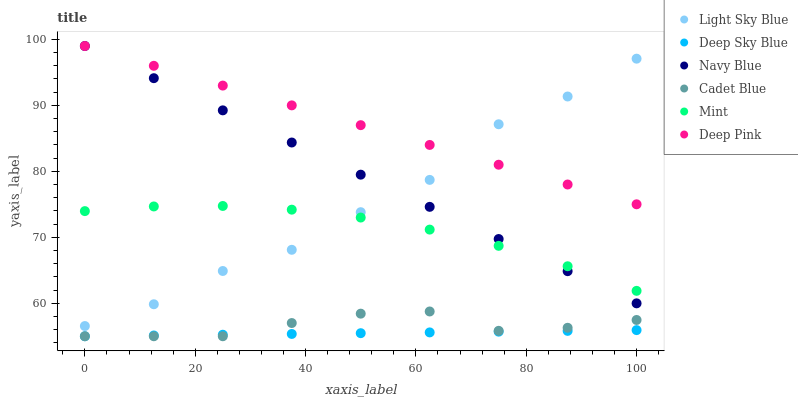Does Deep Sky Blue have the minimum area under the curve?
Answer yes or no. Yes. Does Deep Pink have the maximum area under the curve?
Answer yes or no. Yes. Does Navy Blue have the minimum area under the curve?
Answer yes or no. No. Does Navy Blue have the maximum area under the curve?
Answer yes or no. No. Is Navy Blue the smoothest?
Answer yes or no. Yes. Is Light Sky Blue the roughest?
Answer yes or no. Yes. Is Deep Pink the smoothest?
Answer yes or no. No. Is Deep Pink the roughest?
Answer yes or no. No. Does Cadet Blue have the lowest value?
Answer yes or no. Yes. Does Navy Blue have the lowest value?
Answer yes or no. No. Does Deep Pink have the highest value?
Answer yes or no. Yes. Does Light Sky Blue have the highest value?
Answer yes or no. No. Is Cadet Blue less than Navy Blue?
Answer yes or no. Yes. Is Mint greater than Deep Sky Blue?
Answer yes or no. Yes. Does Deep Pink intersect Navy Blue?
Answer yes or no. Yes. Is Deep Pink less than Navy Blue?
Answer yes or no. No. Is Deep Pink greater than Navy Blue?
Answer yes or no. No. Does Cadet Blue intersect Navy Blue?
Answer yes or no. No. 